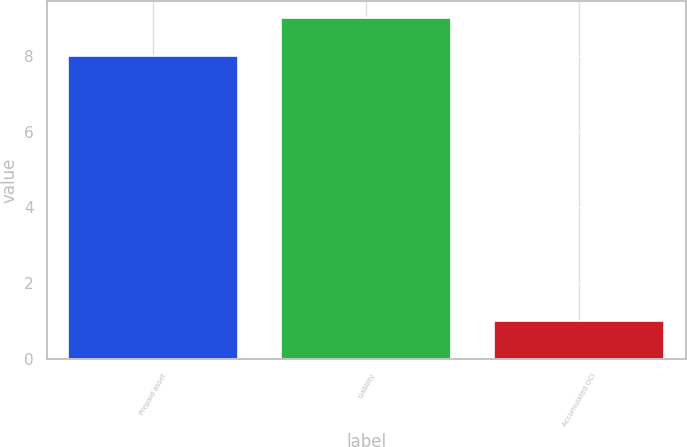Convert chart. <chart><loc_0><loc_0><loc_500><loc_500><bar_chart><fcel>Prepaid asset<fcel>Liability<fcel>Accumulated OCI<nl><fcel>8<fcel>9<fcel>1<nl></chart> 